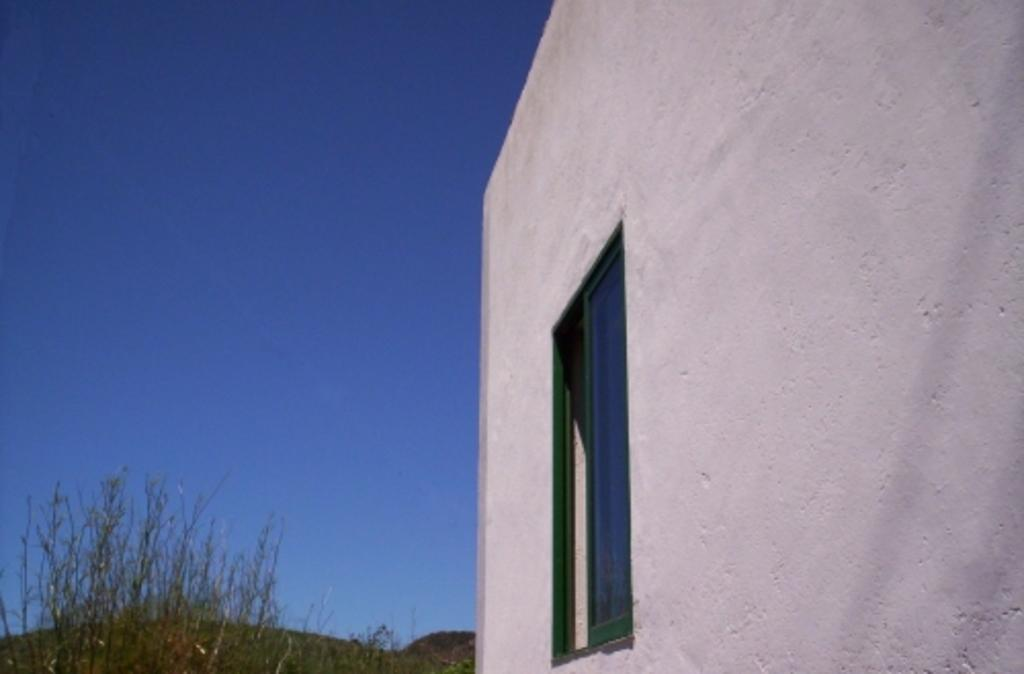What is present on the wall in the image? There is a wall with a window in the image. What can be seen in the background of the image? There are planets and the sky visible in the background of the image. Can you see a person holding an apple and a rabbit in the image? No, there is no person, apple, or rabbit present in the image. 